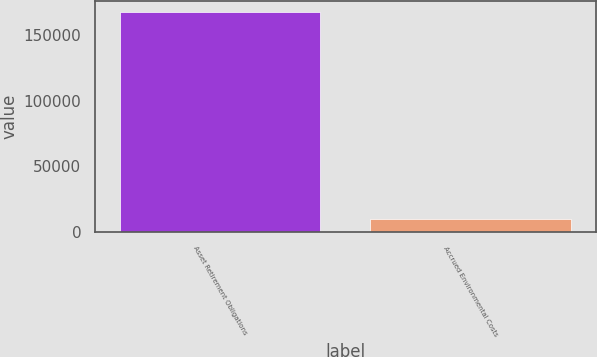Convert chart to OTSL. <chart><loc_0><loc_0><loc_500><loc_500><bar_chart><fcel>Asset Retirement Obligations<fcel>Accrued Environmental Costs<nl><fcel>167757<fcel>9756<nl></chart> 